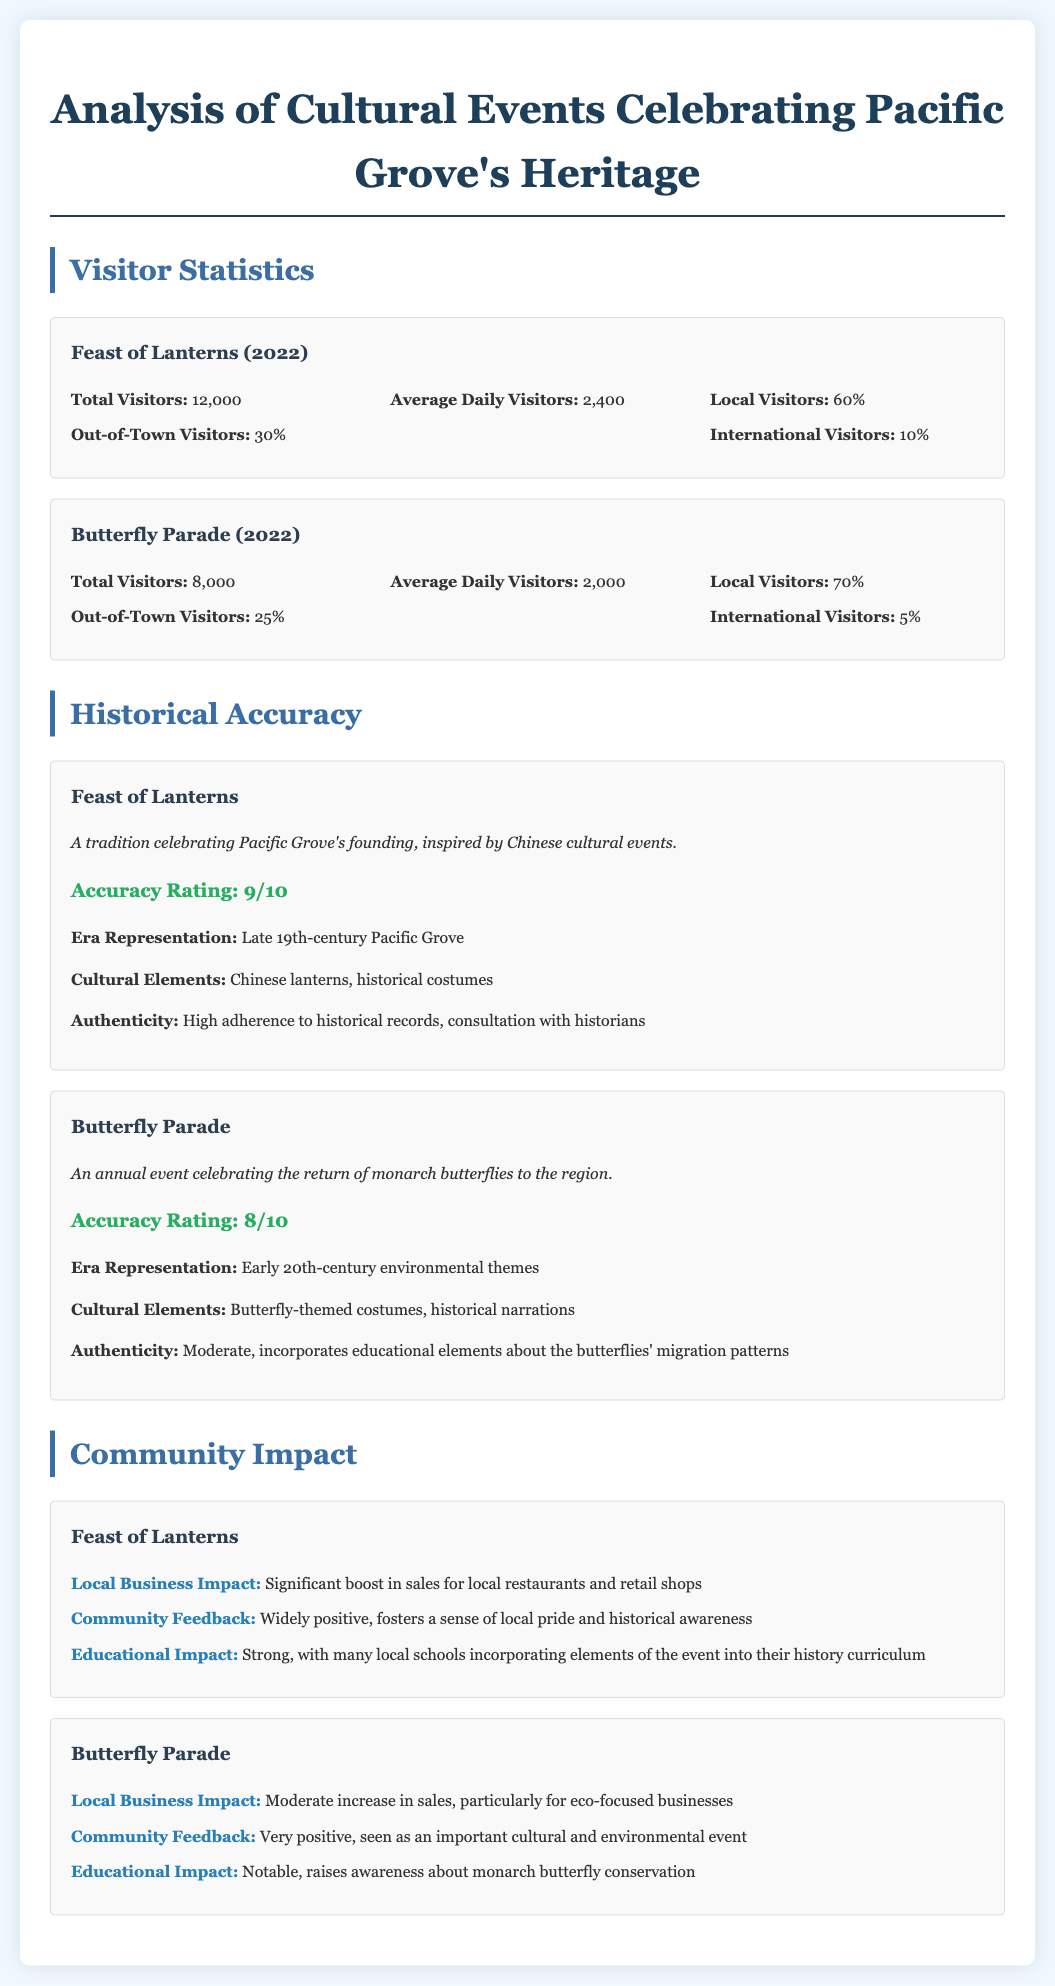what was the total number of visitors for the Feast of Lanterns in 2022? The total number of visitors for the event is listed in the document, which states it was 12,000.
Answer: 12,000 what percentage of visitors to the Butterfly Parade were local? The document indicates that 70% of visitors were local.
Answer: 70% what is the accuracy rating of the Feast of Lanterns? The document provides a specific rating for historical accuracy which is 9 out of 10.
Answer: 9/10 which event has a significant boost in sales for local restaurants? The document explicitly states that the Feast of Lanterns led to a significant boost in sales for local restaurants.
Answer: Feast of Lanterns how many international visitors attended the Butterfly Parade in 2022? The document mentions that 5% of the visitors were international, and with a total of 8,000 visitors, this calculates to 400 international visitors.
Answer: 400 what cultural element is associated with the Feast of Lanterns? The document lists Chinese lanterns as a cultural element for this event.
Answer: Chinese lanterns which event raised awareness about monarch butterfly conservation? According to the document, the Butterfly Parade is noted for raising awareness about monarch butterfly conservation.
Answer: Butterfly Parade what was the community feedback for the Butterfly Parade? The document states the feedback was very positive, highlighting its importance as a cultural and environmental event.
Answer: Very positive 